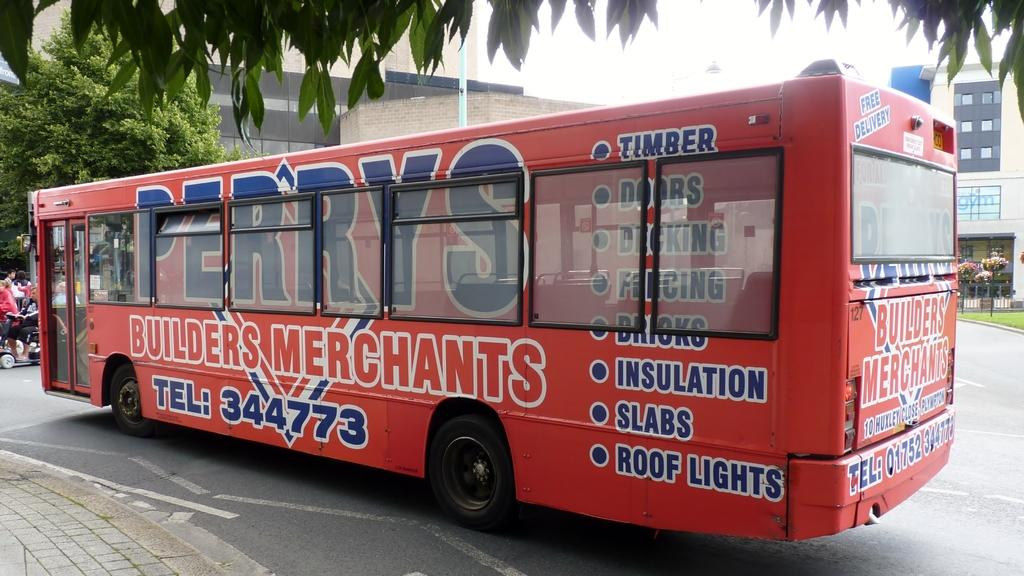What is the main subject of the image? There is a bus in the image. What else can be seen on the road in the image? There are people on the road in the image. What type of vegetation is present in the image? There are trees in the image. What can be seen in the background of the image? There are buildings with windows in the background of the image. Where is the daughter of the bus driver in the image? There is no mention of a bus driver or their daughter in the image, so it cannot be determined. 